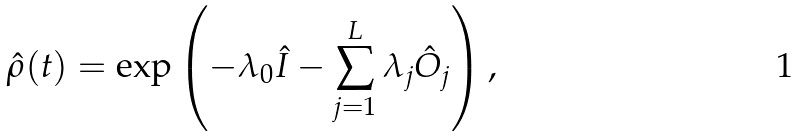<formula> <loc_0><loc_0><loc_500><loc_500>\hat { \rho } ( t ) = \exp \left ( - \lambda _ { 0 } \hat { I } - \sum _ { j = 1 } ^ { L } \lambda _ { j } \hat { O } _ { j } \right ) ,</formula> 